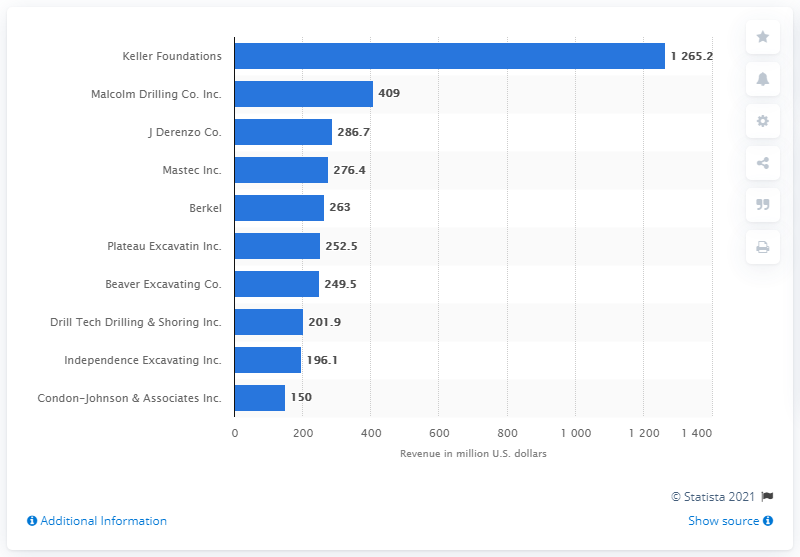Specify some key components in this picture. In 2018, Mastec Inc.'s total revenue was 276.4 million dollars. 